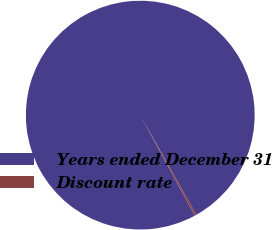Convert chart. <chart><loc_0><loc_0><loc_500><loc_500><pie_chart><fcel>Years ended December 31<fcel>Discount rate<nl><fcel>99.75%<fcel>0.25%<nl></chart> 